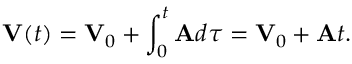<formula> <loc_0><loc_0><loc_500><loc_500>V ( t ) = V _ { 0 } + \int _ { 0 } ^ { t } A d \tau = V _ { 0 } + A t .</formula> 